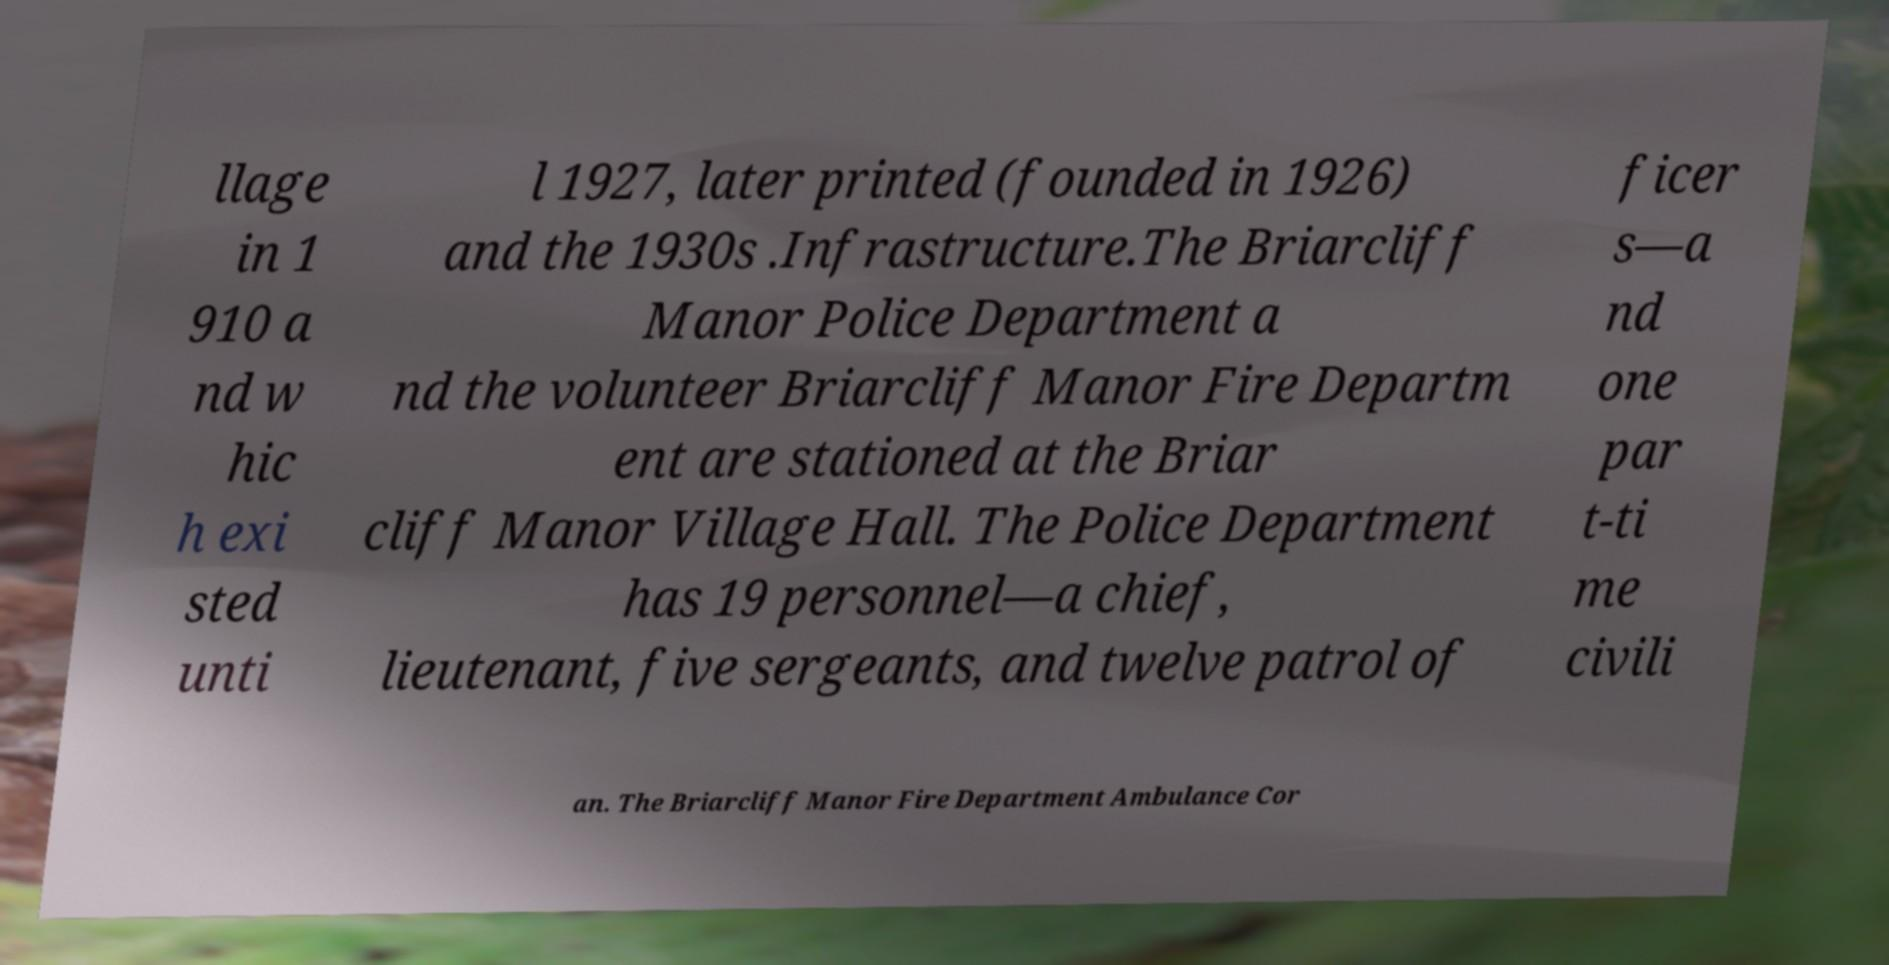There's text embedded in this image that I need extracted. Can you transcribe it verbatim? llage in 1 910 a nd w hic h exi sted unti l 1927, later printed (founded in 1926) and the 1930s .Infrastructure.The Briarcliff Manor Police Department a nd the volunteer Briarcliff Manor Fire Departm ent are stationed at the Briar cliff Manor Village Hall. The Police Department has 19 personnel—a chief, lieutenant, five sergeants, and twelve patrol of ficer s—a nd one par t-ti me civili an. The Briarcliff Manor Fire Department Ambulance Cor 